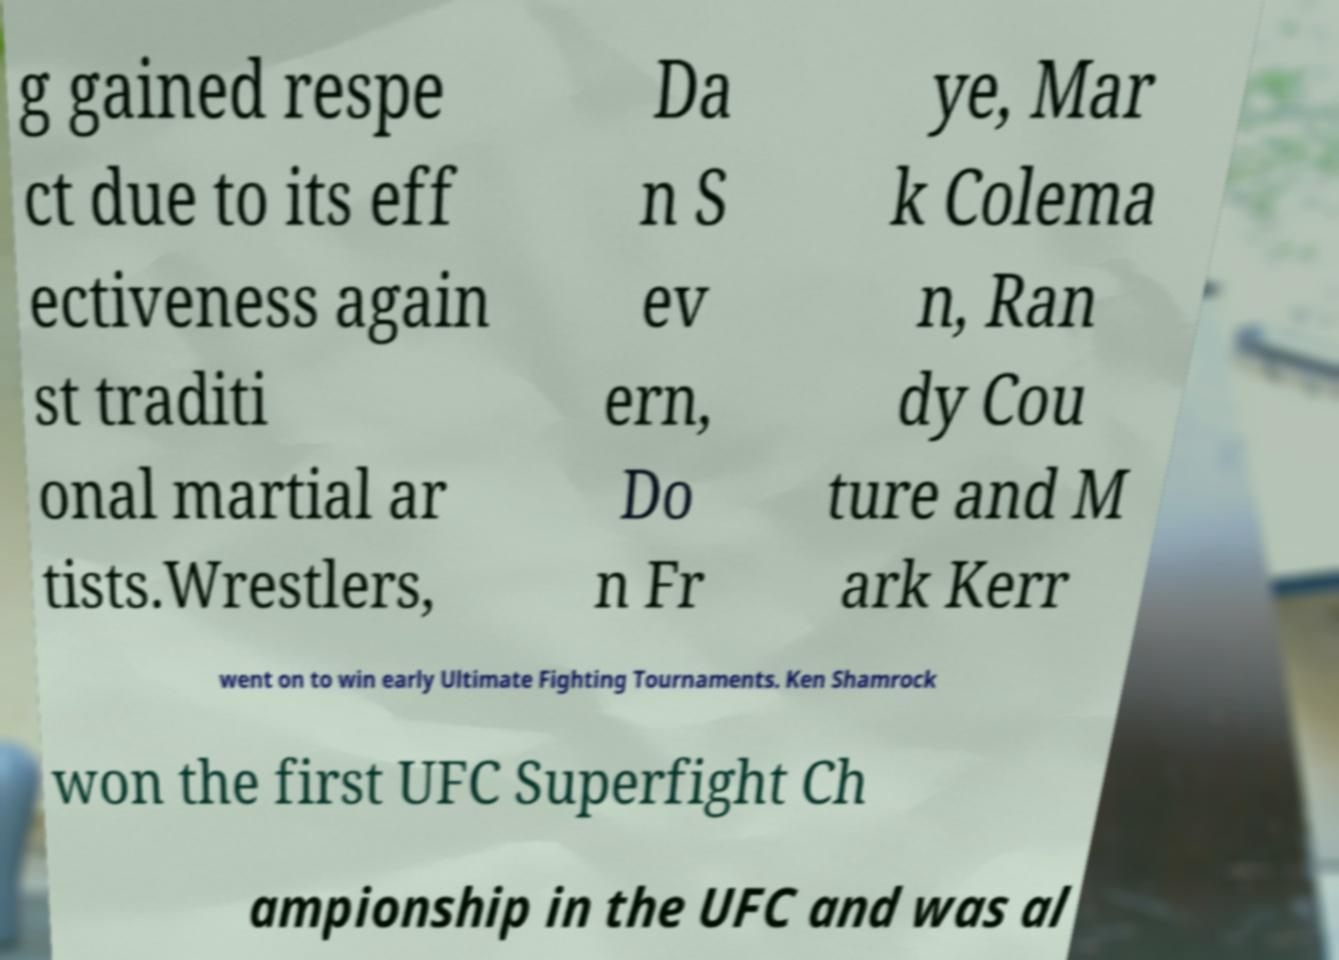Could you extract and type out the text from this image? g gained respe ct due to its eff ectiveness again st traditi onal martial ar tists.Wrestlers, Da n S ev ern, Do n Fr ye, Mar k Colema n, Ran dy Cou ture and M ark Kerr went on to win early Ultimate Fighting Tournaments. Ken Shamrock won the first UFC Superfight Ch ampionship in the UFC and was al 